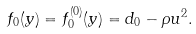Convert formula to latex. <formula><loc_0><loc_0><loc_500><loc_500>f _ { 0 } ( y ) = f _ { 0 } ^ { ( 0 ) } ( y ) = d _ { 0 } - \rho u ^ { 2 } .</formula> 